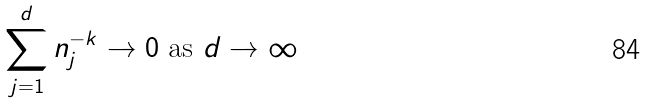Convert formula to latex. <formula><loc_0><loc_0><loc_500><loc_500>\sum _ { j = 1 } ^ { d } n _ { j } ^ { - k } \rightarrow 0 \text { as $d \rightarrow \infty$}</formula> 